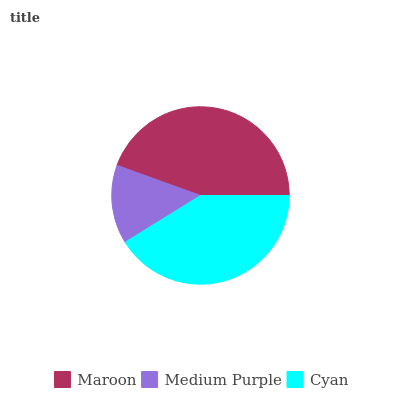Is Medium Purple the minimum?
Answer yes or no. Yes. Is Maroon the maximum?
Answer yes or no. Yes. Is Cyan the minimum?
Answer yes or no. No. Is Cyan the maximum?
Answer yes or no. No. Is Cyan greater than Medium Purple?
Answer yes or no. Yes. Is Medium Purple less than Cyan?
Answer yes or no. Yes. Is Medium Purple greater than Cyan?
Answer yes or no. No. Is Cyan less than Medium Purple?
Answer yes or no. No. Is Cyan the high median?
Answer yes or no. Yes. Is Cyan the low median?
Answer yes or no. Yes. Is Medium Purple the high median?
Answer yes or no. No. Is Maroon the low median?
Answer yes or no. No. 